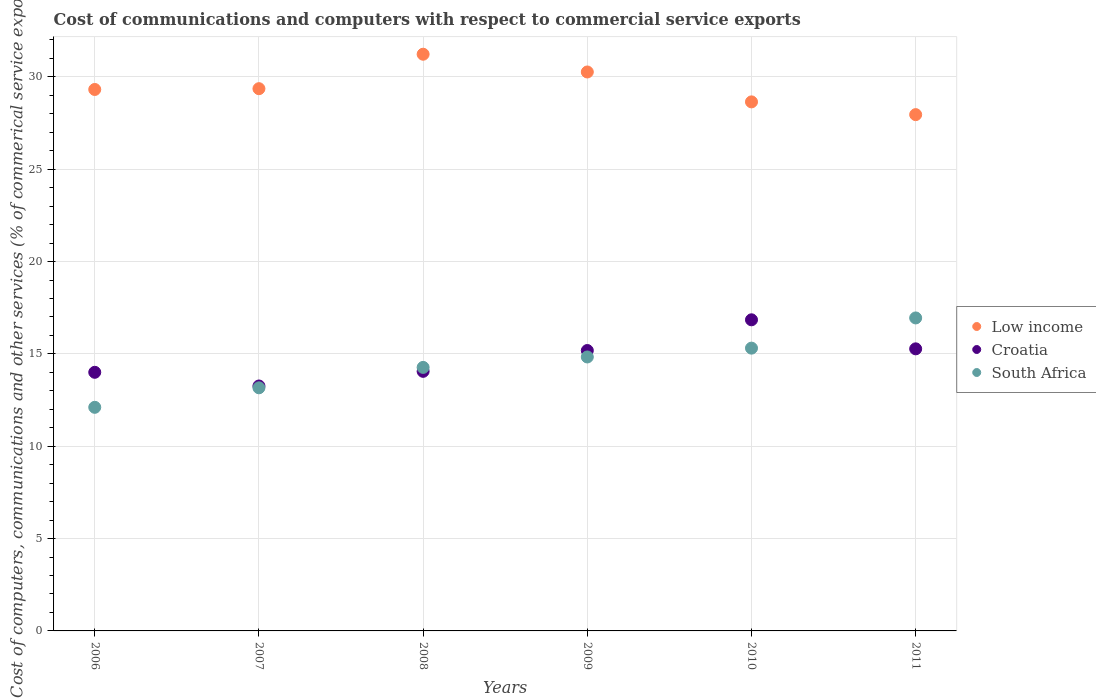Is the number of dotlines equal to the number of legend labels?
Make the answer very short. Yes. What is the cost of communications and computers in South Africa in 2009?
Provide a succinct answer. 14.84. Across all years, what is the maximum cost of communications and computers in Croatia?
Your answer should be very brief. 16.85. Across all years, what is the minimum cost of communications and computers in Low income?
Provide a succinct answer. 27.96. In which year was the cost of communications and computers in Croatia minimum?
Your answer should be compact. 2007. What is the total cost of communications and computers in Croatia in the graph?
Ensure brevity in your answer.  88.63. What is the difference between the cost of communications and computers in Low income in 2007 and that in 2009?
Offer a terse response. -0.9. What is the difference between the cost of communications and computers in Croatia in 2006 and the cost of communications and computers in South Africa in 2011?
Provide a short and direct response. -2.94. What is the average cost of communications and computers in Croatia per year?
Offer a terse response. 14.77. In the year 2010, what is the difference between the cost of communications and computers in South Africa and cost of communications and computers in Croatia?
Ensure brevity in your answer.  -1.53. In how many years, is the cost of communications and computers in Croatia greater than 2 %?
Offer a terse response. 6. What is the ratio of the cost of communications and computers in Croatia in 2009 to that in 2011?
Provide a short and direct response. 0.99. Is the cost of communications and computers in South Africa in 2007 less than that in 2010?
Offer a very short reply. Yes. Is the difference between the cost of communications and computers in South Africa in 2006 and 2008 greater than the difference between the cost of communications and computers in Croatia in 2006 and 2008?
Your answer should be very brief. No. What is the difference between the highest and the second highest cost of communications and computers in South Africa?
Give a very brief answer. 1.64. What is the difference between the highest and the lowest cost of communications and computers in Low income?
Provide a succinct answer. 3.27. In how many years, is the cost of communications and computers in South Africa greater than the average cost of communications and computers in South Africa taken over all years?
Ensure brevity in your answer.  3. Does the cost of communications and computers in South Africa monotonically increase over the years?
Ensure brevity in your answer.  Yes. Is the cost of communications and computers in Low income strictly less than the cost of communications and computers in South Africa over the years?
Give a very brief answer. No. How many dotlines are there?
Your answer should be compact. 3. Are the values on the major ticks of Y-axis written in scientific E-notation?
Provide a short and direct response. No. Does the graph contain any zero values?
Offer a terse response. No. Does the graph contain grids?
Provide a succinct answer. Yes. What is the title of the graph?
Offer a very short reply. Cost of communications and computers with respect to commercial service exports. Does "Vietnam" appear as one of the legend labels in the graph?
Provide a short and direct response. No. What is the label or title of the Y-axis?
Keep it short and to the point. Cost of computers, communications and other services (% of commerical service exports). What is the Cost of computers, communications and other services (% of commerical service exports) of Low income in 2006?
Provide a succinct answer. 29.32. What is the Cost of computers, communications and other services (% of commerical service exports) of Croatia in 2006?
Keep it short and to the point. 14. What is the Cost of computers, communications and other services (% of commerical service exports) of South Africa in 2006?
Make the answer very short. 12.11. What is the Cost of computers, communications and other services (% of commerical service exports) of Low income in 2007?
Your response must be concise. 29.36. What is the Cost of computers, communications and other services (% of commerical service exports) of Croatia in 2007?
Keep it short and to the point. 13.26. What is the Cost of computers, communications and other services (% of commerical service exports) of South Africa in 2007?
Your response must be concise. 13.17. What is the Cost of computers, communications and other services (% of commerical service exports) of Low income in 2008?
Provide a succinct answer. 31.23. What is the Cost of computers, communications and other services (% of commerical service exports) of Croatia in 2008?
Keep it short and to the point. 14.06. What is the Cost of computers, communications and other services (% of commerical service exports) of South Africa in 2008?
Give a very brief answer. 14.27. What is the Cost of computers, communications and other services (% of commerical service exports) in Low income in 2009?
Provide a short and direct response. 30.27. What is the Cost of computers, communications and other services (% of commerical service exports) of Croatia in 2009?
Provide a succinct answer. 15.18. What is the Cost of computers, communications and other services (% of commerical service exports) in South Africa in 2009?
Give a very brief answer. 14.84. What is the Cost of computers, communications and other services (% of commerical service exports) in Low income in 2010?
Make the answer very short. 28.65. What is the Cost of computers, communications and other services (% of commerical service exports) in Croatia in 2010?
Make the answer very short. 16.85. What is the Cost of computers, communications and other services (% of commerical service exports) in South Africa in 2010?
Your answer should be very brief. 15.31. What is the Cost of computers, communications and other services (% of commerical service exports) of Low income in 2011?
Keep it short and to the point. 27.96. What is the Cost of computers, communications and other services (% of commerical service exports) of Croatia in 2011?
Your answer should be very brief. 15.28. What is the Cost of computers, communications and other services (% of commerical service exports) in South Africa in 2011?
Provide a succinct answer. 16.95. Across all years, what is the maximum Cost of computers, communications and other services (% of commerical service exports) in Low income?
Provide a short and direct response. 31.23. Across all years, what is the maximum Cost of computers, communications and other services (% of commerical service exports) in Croatia?
Offer a terse response. 16.85. Across all years, what is the maximum Cost of computers, communications and other services (% of commerical service exports) in South Africa?
Provide a succinct answer. 16.95. Across all years, what is the minimum Cost of computers, communications and other services (% of commerical service exports) in Low income?
Your response must be concise. 27.96. Across all years, what is the minimum Cost of computers, communications and other services (% of commerical service exports) of Croatia?
Offer a terse response. 13.26. Across all years, what is the minimum Cost of computers, communications and other services (% of commerical service exports) of South Africa?
Offer a terse response. 12.11. What is the total Cost of computers, communications and other services (% of commerical service exports) in Low income in the graph?
Offer a very short reply. 176.79. What is the total Cost of computers, communications and other services (% of commerical service exports) in Croatia in the graph?
Offer a very short reply. 88.63. What is the total Cost of computers, communications and other services (% of commerical service exports) in South Africa in the graph?
Your answer should be compact. 86.64. What is the difference between the Cost of computers, communications and other services (% of commerical service exports) in Low income in 2006 and that in 2007?
Your response must be concise. -0.04. What is the difference between the Cost of computers, communications and other services (% of commerical service exports) of Croatia in 2006 and that in 2007?
Provide a succinct answer. 0.74. What is the difference between the Cost of computers, communications and other services (% of commerical service exports) of South Africa in 2006 and that in 2007?
Ensure brevity in your answer.  -1.06. What is the difference between the Cost of computers, communications and other services (% of commerical service exports) of Low income in 2006 and that in 2008?
Your answer should be very brief. -1.91. What is the difference between the Cost of computers, communications and other services (% of commerical service exports) of Croatia in 2006 and that in 2008?
Your answer should be very brief. -0.05. What is the difference between the Cost of computers, communications and other services (% of commerical service exports) in South Africa in 2006 and that in 2008?
Your answer should be very brief. -2.16. What is the difference between the Cost of computers, communications and other services (% of commerical service exports) of Low income in 2006 and that in 2009?
Your response must be concise. -0.95. What is the difference between the Cost of computers, communications and other services (% of commerical service exports) of Croatia in 2006 and that in 2009?
Provide a succinct answer. -1.18. What is the difference between the Cost of computers, communications and other services (% of commerical service exports) in South Africa in 2006 and that in 2009?
Make the answer very short. -2.73. What is the difference between the Cost of computers, communications and other services (% of commerical service exports) of Low income in 2006 and that in 2010?
Ensure brevity in your answer.  0.67. What is the difference between the Cost of computers, communications and other services (% of commerical service exports) of Croatia in 2006 and that in 2010?
Ensure brevity in your answer.  -2.84. What is the difference between the Cost of computers, communications and other services (% of commerical service exports) of South Africa in 2006 and that in 2010?
Offer a very short reply. -3.21. What is the difference between the Cost of computers, communications and other services (% of commerical service exports) of Low income in 2006 and that in 2011?
Offer a very short reply. 1.36. What is the difference between the Cost of computers, communications and other services (% of commerical service exports) of Croatia in 2006 and that in 2011?
Your response must be concise. -1.27. What is the difference between the Cost of computers, communications and other services (% of commerical service exports) of South Africa in 2006 and that in 2011?
Ensure brevity in your answer.  -4.84. What is the difference between the Cost of computers, communications and other services (% of commerical service exports) of Low income in 2007 and that in 2008?
Your answer should be compact. -1.87. What is the difference between the Cost of computers, communications and other services (% of commerical service exports) in Croatia in 2007 and that in 2008?
Provide a succinct answer. -0.79. What is the difference between the Cost of computers, communications and other services (% of commerical service exports) in South Africa in 2007 and that in 2008?
Your answer should be compact. -1.11. What is the difference between the Cost of computers, communications and other services (% of commerical service exports) of Low income in 2007 and that in 2009?
Make the answer very short. -0.9. What is the difference between the Cost of computers, communications and other services (% of commerical service exports) in Croatia in 2007 and that in 2009?
Offer a very short reply. -1.92. What is the difference between the Cost of computers, communications and other services (% of commerical service exports) in South Africa in 2007 and that in 2009?
Ensure brevity in your answer.  -1.67. What is the difference between the Cost of computers, communications and other services (% of commerical service exports) in Low income in 2007 and that in 2010?
Offer a terse response. 0.71. What is the difference between the Cost of computers, communications and other services (% of commerical service exports) of Croatia in 2007 and that in 2010?
Your response must be concise. -3.58. What is the difference between the Cost of computers, communications and other services (% of commerical service exports) of South Africa in 2007 and that in 2010?
Your answer should be compact. -2.15. What is the difference between the Cost of computers, communications and other services (% of commerical service exports) of Low income in 2007 and that in 2011?
Provide a succinct answer. 1.41. What is the difference between the Cost of computers, communications and other services (% of commerical service exports) of Croatia in 2007 and that in 2011?
Provide a succinct answer. -2.01. What is the difference between the Cost of computers, communications and other services (% of commerical service exports) of South Africa in 2007 and that in 2011?
Offer a very short reply. -3.78. What is the difference between the Cost of computers, communications and other services (% of commerical service exports) in Low income in 2008 and that in 2009?
Make the answer very short. 0.96. What is the difference between the Cost of computers, communications and other services (% of commerical service exports) in Croatia in 2008 and that in 2009?
Your answer should be compact. -1.13. What is the difference between the Cost of computers, communications and other services (% of commerical service exports) in South Africa in 2008 and that in 2009?
Ensure brevity in your answer.  -0.56. What is the difference between the Cost of computers, communications and other services (% of commerical service exports) of Low income in 2008 and that in 2010?
Your answer should be very brief. 2.58. What is the difference between the Cost of computers, communications and other services (% of commerical service exports) in Croatia in 2008 and that in 2010?
Offer a very short reply. -2.79. What is the difference between the Cost of computers, communications and other services (% of commerical service exports) in South Africa in 2008 and that in 2010?
Your answer should be compact. -1.04. What is the difference between the Cost of computers, communications and other services (% of commerical service exports) of Low income in 2008 and that in 2011?
Your answer should be compact. 3.27. What is the difference between the Cost of computers, communications and other services (% of commerical service exports) in Croatia in 2008 and that in 2011?
Your answer should be compact. -1.22. What is the difference between the Cost of computers, communications and other services (% of commerical service exports) in South Africa in 2008 and that in 2011?
Provide a succinct answer. -2.68. What is the difference between the Cost of computers, communications and other services (% of commerical service exports) of Low income in 2009 and that in 2010?
Offer a terse response. 1.62. What is the difference between the Cost of computers, communications and other services (% of commerical service exports) in Croatia in 2009 and that in 2010?
Offer a terse response. -1.66. What is the difference between the Cost of computers, communications and other services (% of commerical service exports) of South Africa in 2009 and that in 2010?
Give a very brief answer. -0.48. What is the difference between the Cost of computers, communications and other services (% of commerical service exports) of Low income in 2009 and that in 2011?
Make the answer very short. 2.31. What is the difference between the Cost of computers, communications and other services (% of commerical service exports) in Croatia in 2009 and that in 2011?
Provide a succinct answer. -0.09. What is the difference between the Cost of computers, communications and other services (% of commerical service exports) of South Africa in 2009 and that in 2011?
Provide a short and direct response. -2.11. What is the difference between the Cost of computers, communications and other services (% of commerical service exports) in Low income in 2010 and that in 2011?
Offer a very short reply. 0.69. What is the difference between the Cost of computers, communications and other services (% of commerical service exports) in Croatia in 2010 and that in 2011?
Give a very brief answer. 1.57. What is the difference between the Cost of computers, communications and other services (% of commerical service exports) in South Africa in 2010 and that in 2011?
Offer a very short reply. -1.64. What is the difference between the Cost of computers, communications and other services (% of commerical service exports) of Low income in 2006 and the Cost of computers, communications and other services (% of commerical service exports) of Croatia in 2007?
Offer a very short reply. 16.06. What is the difference between the Cost of computers, communications and other services (% of commerical service exports) in Low income in 2006 and the Cost of computers, communications and other services (% of commerical service exports) in South Africa in 2007?
Offer a very short reply. 16.16. What is the difference between the Cost of computers, communications and other services (% of commerical service exports) of Croatia in 2006 and the Cost of computers, communications and other services (% of commerical service exports) of South Africa in 2007?
Provide a short and direct response. 0.84. What is the difference between the Cost of computers, communications and other services (% of commerical service exports) in Low income in 2006 and the Cost of computers, communications and other services (% of commerical service exports) in Croatia in 2008?
Offer a very short reply. 15.26. What is the difference between the Cost of computers, communications and other services (% of commerical service exports) of Low income in 2006 and the Cost of computers, communications and other services (% of commerical service exports) of South Africa in 2008?
Make the answer very short. 15.05. What is the difference between the Cost of computers, communications and other services (% of commerical service exports) in Croatia in 2006 and the Cost of computers, communications and other services (% of commerical service exports) in South Africa in 2008?
Keep it short and to the point. -0.27. What is the difference between the Cost of computers, communications and other services (% of commerical service exports) in Low income in 2006 and the Cost of computers, communications and other services (% of commerical service exports) in Croatia in 2009?
Your answer should be compact. 14.14. What is the difference between the Cost of computers, communications and other services (% of commerical service exports) of Low income in 2006 and the Cost of computers, communications and other services (% of commerical service exports) of South Africa in 2009?
Make the answer very short. 14.49. What is the difference between the Cost of computers, communications and other services (% of commerical service exports) in Croatia in 2006 and the Cost of computers, communications and other services (% of commerical service exports) in South Africa in 2009?
Your response must be concise. -0.83. What is the difference between the Cost of computers, communications and other services (% of commerical service exports) in Low income in 2006 and the Cost of computers, communications and other services (% of commerical service exports) in Croatia in 2010?
Keep it short and to the point. 12.47. What is the difference between the Cost of computers, communications and other services (% of commerical service exports) in Low income in 2006 and the Cost of computers, communications and other services (% of commerical service exports) in South Africa in 2010?
Offer a terse response. 14.01. What is the difference between the Cost of computers, communications and other services (% of commerical service exports) in Croatia in 2006 and the Cost of computers, communications and other services (% of commerical service exports) in South Africa in 2010?
Your answer should be compact. -1.31. What is the difference between the Cost of computers, communications and other services (% of commerical service exports) of Low income in 2006 and the Cost of computers, communications and other services (% of commerical service exports) of Croatia in 2011?
Make the answer very short. 14.05. What is the difference between the Cost of computers, communications and other services (% of commerical service exports) of Low income in 2006 and the Cost of computers, communications and other services (% of commerical service exports) of South Africa in 2011?
Offer a very short reply. 12.37. What is the difference between the Cost of computers, communications and other services (% of commerical service exports) in Croatia in 2006 and the Cost of computers, communications and other services (% of commerical service exports) in South Africa in 2011?
Offer a very short reply. -2.94. What is the difference between the Cost of computers, communications and other services (% of commerical service exports) of Low income in 2007 and the Cost of computers, communications and other services (% of commerical service exports) of Croatia in 2008?
Give a very brief answer. 15.31. What is the difference between the Cost of computers, communications and other services (% of commerical service exports) in Low income in 2007 and the Cost of computers, communications and other services (% of commerical service exports) in South Africa in 2008?
Make the answer very short. 15.09. What is the difference between the Cost of computers, communications and other services (% of commerical service exports) of Croatia in 2007 and the Cost of computers, communications and other services (% of commerical service exports) of South Africa in 2008?
Your answer should be compact. -1.01. What is the difference between the Cost of computers, communications and other services (% of commerical service exports) in Low income in 2007 and the Cost of computers, communications and other services (% of commerical service exports) in Croatia in 2009?
Give a very brief answer. 14.18. What is the difference between the Cost of computers, communications and other services (% of commerical service exports) in Low income in 2007 and the Cost of computers, communications and other services (% of commerical service exports) in South Africa in 2009?
Offer a very short reply. 14.53. What is the difference between the Cost of computers, communications and other services (% of commerical service exports) in Croatia in 2007 and the Cost of computers, communications and other services (% of commerical service exports) in South Africa in 2009?
Offer a very short reply. -1.57. What is the difference between the Cost of computers, communications and other services (% of commerical service exports) in Low income in 2007 and the Cost of computers, communications and other services (% of commerical service exports) in Croatia in 2010?
Your response must be concise. 12.52. What is the difference between the Cost of computers, communications and other services (% of commerical service exports) in Low income in 2007 and the Cost of computers, communications and other services (% of commerical service exports) in South Africa in 2010?
Ensure brevity in your answer.  14.05. What is the difference between the Cost of computers, communications and other services (% of commerical service exports) of Croatia in 2007 and the Cost of computers, communications and other services (% of commerical service exports) of South Africa in 2010?
Your answer should be very brief. -2.05. What is the difference between the Cost of computers, communications and other services (% of commerical service exports) of Low income in 2007 and the Cost of computers, communications and other services (% of commerical service exports) of Croatia in 2011?
Ensure brevity in your answer.  14.09. What is the difference between the Cost of computers, communications and other services (% of commerical service exports) of Low income in 2007 and the Cost of computers, communications and other services (% of commerical service exports) of South Africa in 2011?
Your answer should be very brief. 12.41. What is the difference between the Cost of computers, communications and other services (% of commerical service exports) of Croatia in 2007 and the Cost of computers, communications and other services (% of commerical service exports) of South Africa in 2011?
Keep it short and to the point. -3.69. What is the difference between the Cost of computers, communications and other services (% of commerical service exports) in Low income in 2008 and the Cost of computers, communications and other services (% of commerical service exports) in Croatia in 2009?
Keep it short and to the point. 16.05. What is the difference between the Cost of computers, communications and other services (% of commerical service exports) in Low income in 2008 and the Cost of computers, communications and other services (% of commerical service exports) in South Africa in 2009?
Offer a very short reply. 16.39. What is the difference between the Cost of computers, communications and other services (% of commerical service exports) of Croatia in 2008 and the Cost of computers, communications and other services (% of commerical service exports) of South Africa in 2009?
Offer a terse response. -0.78. What is the difference between the Cost of computers, communications and other services (% of commerical service exports) of Low income in 2008 and the Cost of computers, communications and other services (% of commerical service exports) of Croatia in 2010?
Give a very brief answer. 14.38. What is the difference between the Cost of computers, communications and other services (% of commerical service exports) in Low income in 2008 and the Cost of computers, communications and other services (% of commerical service exports) in South Africa in 2010?
Provide a short and direct response. 15.92. What is the difference between the Cost of computers, communications and other services (% of commerical service exports) of Croatia in 2008 and the Cost of computers, communications and other services (% of commerical service exports) of South Africa in 2010?
Provide a succinct answer. -1.26. What is the difference between the Cost of computers, communications and other services (% of commerical service exports) of Low income in 2008 and the Cost of computers, communications and other services (% of commerical service exports) of Croatia in 2011?
Provide a succinct answer. 15.95. What is the difference between the Cost of computers, communications and other services (% of commerical service exports) of Low income in 2008 and the Cost of computers, communications and other services (% of commerical service exports) of South Africa in 2011?
Make the answer very short. 14.28. What is the difference between the Cost of computers, communications and other services (% of commerical service exports) of Croatia in 2008 and the Cost of computers, communications and other services (% of commerical service exports) of South Africa in 2011?
Your answer should be compact. -2.89. What is the difference between the Cost of computers, communications and other services (% of commerical service exports) in Low income in 2009 and the Cost of computers, communications and other services (% of commerical service exports) in Croatia in 2010?
Provide a short and direct response. 13.42. What is the difference between the Cost of computers, communications and other services (% of commerical service exports) of Low income in 2009 and the Cost of computers, communications and other services (% of commerical service exports) of South Africa in 2010?
Provide a succinct answer. 14.95. What is the difference between the Cost of computers, communications and other services (% of commerical service exports) in Croatia in 2009 and the Cost of computers, communications and other services (% of commerical service exports) in South Africa in 2010?
Your response must be concise. -0.13. What is the difference between the Cost of computers, communications and other services (% of commerical service exports) of Low income in 2009 and the Cost of computers, communications and other services (% of commerical service exports) of Croatia in 2011?
Keep it short and to the point. 14.99. What is the difference between the Cost of computers, communications and other services (% of commerical service exports) in Low income in 2009 and the Cost of computers, communications and other services (% of commerical service exports) in South Africa in 2011?
Offer a terse response. 13.32. What is the difference between the Cost of computers, communications and other services (% of commerical service exports) of Croatia in 2009 and the Cost of computers, communications and other services (% of commerical service exports) of South Africa in 2011?
Provide a short and direct response. -1.76. What is the difference between the Cost of computers, communications and other services (% of commerical service exports) of Low income in 2010 and the Cost of computers, communications and other services (% of commerical service exports) of Croatia in 2011?
Make the answer very short. 13.37. What is the difference between the Cost of computers, communications and other services (% of commerical service exports) in Croatia in 2010 and the Cost of computers, communications and other services (% of commerical service exports) in South Africa in 2011?
Provide a succinct answer. -0.1. What is the average Cost of computers, communications and other services (% of commerical service exports) in Low income per year?
Provide a short and direct response. 29.46. What is the average Cost of computers, communications and other services (% of commerical service exports) of Croatia per year?
Ensure brevity in your answer.  14.77. What is the average Cost of computers, communications and other services (% of commerical service exports) in South Africa per year?
Your response must be concise. 14.44. In the year 2006, what is the difference between the Cost of computers, communications and other services (% of commerical service exports) in Low income and Cost of computers, communications and other services (% of commerical service exports) in Croatia?
Ensure brevity in your answer.  15.32. In the year 2006, what is the difference between the Cost of computers, communications and other services (% of commerical service exports) of Low income and Cost of computers, communications and other services (% of commerical service exports) of South Africa?
Ensure brevity in your answer.  17.21. In the year 2006, what is the difference between the Cost of computers, communications and other services (% of commerical service exports) of Croatia and Cost of computers, communications and other services (% of commerical service exports) of South Africa?
Give a very brief answer. 1.9. In the year 2007, what is the difference between the Cost of computers, communications and other services (% of commerical service exports) in Low income and Cost of computers, communications and other services (% of commerical service exports) in Croatia?
Ensure brevity in your answer.  16.1. In the year 2007, what is the difference between the Cost of computers, communications and other services (% of commerical service exports) in Low income and Cost of computers, communications and other services (% of commerical service exports) in South Africa?
Your answer should be compact. 16.2. In the year 2007, what is the difference between the Cost of computers, communications and other services (% of commerical service exports) in Croatia and Cost of computers, communications and other services (% of commerical service exports) in South Africa?
Ensure brevity in your answer.  0.1. In the year 2008, what is the difference between the Cost of computers, communications and other services (% of commerical service exports) of Low income and Cost of computers, communications and other services (% of commerical service exports) of Croatia?
Offer a terse response. 17.17. In the year 2008, what is the difference between the Cost of computers, communications and other services (% of commerical service exports) in Low income and Cost of computers, communications and other services (% of commerical service exports) in South Africa?
Offer a terse response. 16.96. In the year 2008, what is the difference between the Cost of computers, communications and other services (% of commerical service exports) in Croatia and Cost of computers, communications and other services (% of commerical service exports) in South Africa?
Your answer should be compact. -0.21. In the year 2009, what is the difference between the Cost of computers, communications and other services (% of commerical service exports) in Low income and Cost of computers, communications and other services (% of commerical service exports) in Croatia?
Offer a very short reply. 15.08. In the year 2009, what is the difference between the Cost of computers, communications and other services (% of commerical service exports) of Low income and Cost of computers, communications and other services (% of commerical service exports) of South Africa?
Your answer should be compact. 15.43. In the year 2009, what is the difference between the Cost of computers, communications and other services (% of commerical service exports) of Croatia and Cost of computers, communications and other services (% of commerical service exports) of South Africa?
Provide a short and direct response. 0.35. In the year 2010, what is the difference between the Cost of computers, communications and other services (% of commerical service exports) in Low income and Cost of computers, communications and other services (% of commerical service exports) in Croatia?
Keep it short and to the point. 11.8. In the year 2010, what is the difference between the Cost of computers, communications and other services (% of commerical service exports) of Low income and Cost of computers, communications and other services (% of commerical service exports) of South Africa?
Keep it short and to the point. 13.34. In the year 2010, what is the difference between the Cost of computers, communications and other services (% of commerical service exports) of Croatia and Cost of computers, communications and other services (% of commerical service exports) of South Africa?
Give a very brief answer. 1.53. In the year 2011, what is the difference between the Cost of computers, communications and other services (% of commerical service exports) of Low income and Cost of computers, communications and other services (% of commerical service exports) of Croatia?
Provide a short and direct response. 12.68. In the year 2011, what is the difference between the Cost of computers, communications and other services (% of commerical service exports) of Low income and Cost of computers, communications and other services (% of commerical service exports) of South Africa?
Your response must be concise. 11.01. In the year 2011, what is the difference between the Cost of computers, communications and other services (% of commerical service exports) in Croatia and Cost of computers, communications and other services (% of commerical service exports) in South Africa?
Offer a terse response. -1.67. What is the ratio of the Cost of computers, communications and other services (% of commerical service exports) in Low income in 2006 to that in 2007?
Provide a short and direct response. 1. What is the ratio of the Cost of computers, communications and other services (% of commerical service exports) in Croatia in 2006 to that in 2007?
Ensure brevity in your answer.  1.06. What is the ratio of the Cost of computers, communications and other services (% of commerical service exports) in South Africa in 2006 to that in 2007?
Offer a terse response. 0.92. What is the ratio of the Cost of computers, communications and other services (% of commerical service exports) in Low income in 2006 to that in 2008?
Offer a terse response. 0.94. What is the ratio of the Cost of computers, communications and other services (% of commerical service exports) of South Africa in 2006 to that in 2008?
Provide a succinct answer. 0.85. What is the ratio of the Cost of computers, communications and other services (% of commerical service exports) in Low income in 2006 to that in 2009?
Your answer should be compact. 0.97. What is the ratio of the Cost of computers, communications and other services (% of commerical service exports) of Croatia in 2006 to that in 2009?
Your answer should be compact. 0.92. What is the ratio of the Cost of computers, communications and other services (% of commerical service exports) in South Africa in 2006 to that in 2009?
Your answer should be very brief. 0.82. What is the ratio of the Cost of computers, communications and other services (% of commerical service exports) in Low income in 2006 to that in 2010?
Give a very brief answer. 1.02. What is the ratio of the Cost of computers, communications and other services (% of commerical service exports) in Croatia in 2006 to that in 2010?
Provide a succinct answer. 0.83. What is the ratio of the Cost of computers, communications and other services (% of commerical service exports) in South Africa in 2006 to that in 2010?
Keep it short and to the point. 0.79. What is the ratio of the Cost of computers, communications and other services (% of commerical service exports) of Low income in 2006 to that in 2011?
Ensure brevity in your answer.  1.05. What is the ratio of the Cost of computers, communications and other services (% of commerical service exports) of Croatia in 2006 to that in 2011?
Provide a short and direct response. 0.92. What is the ratio of the Cost of computers, communications and other services (% of commerical service exports) of South Africa in 2006 to that in 2011?
Your response must be concise. 0.71. What is the ratio of the Cost of computers, communications and other services (% of commerical service exports) of Low income in 2007 to that in 2008?
Keep it short and to the point. 0.94. What is the ratio of the Cost of computers, communications and other services (% of commerical service exports) of Croatia in 2007 to that in 2008?
Your response must be concise. 0.94. What is the ratio of the Cost of computers, communications and other services (% of commerical service exports) in South Africa in 2007 to that in 2008?
Provide a short and direct response. 0.92. What is the ratio of the Cost of computers, communications and other services (% of commerical service exports) of Low income in 2007 to that in 2009?
Offer a terse response. 0.97. What is the ratio of the Cost of computers, communications and other services (% of commerical service exports) in Croatia in 2007 to that in 2009?
Give a very brief answer. 0.87. What is the ratio of the Cost of computers, communications and other services (% of commerical service exports) in South Africa in 2007 to that in 2009?
Your response must be concise. 0.89. What is the ratio of the Cost of computers, communications and other services (% of commerical service exports) of Croatia in 2007 to that in 2010?
Keep it short and to the point. 0.79. What is the ratio of the Cost of computers, communications and other services (% of commerical service exports) in South Africa in 2007 to that in 2010?
Give a very brief answer. 0.86. What is the ratio of the Cost of computers, communications and other services (% of commerical service exports) of Low income in 2007 to that in 2011?
Your answer should be very brief. 1.05. What is the ratio of the Cost of computers, communications and other services (% of commerical service exports) of Croatia in 2007 to that in 2011?
Your answer should be compact. 0.87. What is the ratio of the Cost of computers, communications and other services (% of commerical service exports) of South Africa in 2007 to that in 2011?
Your answer should be very brief. 0.78. What is the ratio of the Cost of computers, communications and other services (% of commerical service exports) of Low income in 2008 to that in 2009?
Provide a succinct answer. 1.03. What is the ratio of the Cost of computers, communications and other services (% of commerical service exports) of Croatia in 2008 to that in 2009?
Your response must be concise. 0.93. What is the ratio of the Cost of computers, communications and other services (% of commerical service exports) of South Africa in 2008 to that in 2009?
Your answer should be very brief. 0.96. What is the ratio of the Cost of computers, communications and other services (% of commerical service exports) of Low income in 2008 to that in 2010?
Ensure brevity in your answer.  1.09. What is the ratio of the Cost of computers, communications and other services (% of commerical service exports) in Croatia in 2008 to that in 2010?
Keep it short and to the point. 0.83. What is the ratio of the Cost of computers, communications and other services (% of commerical service exports) in South Africa in 2008 to that in 2010?
Make the answer very short. 0.93. What is the ratio of the Cost of computers, communications and other services (% of commerical service exports) of Low income in 2008 to that in 2011?
Ensure brevity in your answer.  1.12. What is the ratio of the Cost of computers, communications and other services (% of commerical service exports) of Croatia in 2008 to that in 2011?
Ensure brevity in your answer.  0.92. What is the ratio of the Cost of computers, communications and other services (% of commerical service exports) of South Africa in 2008 to that in 2011?
Your response must be concise. 0.84. What is the ratio of the Cost of computers, communications and other services (% of commerical service exports) in Low income in 2009 to that in 2010?
Provide a short and direct response. 1.06. What is the ratio of the Cost of computers, communications and other services (% of commerical service exports) of Croatia in 2009 to that in 2010?
Your answer should be compact. 0.9. What is the ratio of the Cost of computers, communications and other services (% of commerical service exports) of South Africa in 2009 to that in 2010?
Make the answer very short. 0.97. What is the ratio of the Cost of computers, communications and other services (% of commerical service exports) of Low income in 2009 to that in 2011?
Your response must be concise. 1.08. What is the ratio of the Cost of computers, communications and other services (% of commerical service exports) of Croatia in 2009 to that in 2011?
Your answer should be compact. 0.99. What is the ratio of the Cost of computers, communications and other services (% of commerical service exports) of South Africa in 2009 to that in 2011?
Offer a terse response. 0.88. What is the ratio of the Cost of computers, communications and other services (% of commerical service exports) in Low income in 2010 to that in 2011?
Ensure brevity in your answer.  1.02. What is the ratio of the Cost of computers, communications and other services (% of commerical service exports) in Croatia in 2010 to that in 2011?
Your answer should be very brief. 1.1. What is the ratio of the Cost of computers, communications and other services (% of commerical service exports) of South Africa in 2010 to that in 2011?
Provide a succinct answer. 0.9. What is the difference between the highest and the second highest Cost of computers, communications and other services (% of commerical service exports) in Low income?
Offer a terse response. 0.96. What is the difference between the highest and the second highest Cost of computers, communications and other services (% of commerical service exports) in Croatia?
Make the answer very short. 1.57. What is the difference between the highest and the second highest Cost of computers, communications and other services (% of commerical service exports) of South Africa?
Make the answer very short. 1.64. What is the difference between the highest and the lowest Cost of computers, communications and other services (% of commerical service exports) of Low income?
Offer a terse response. 3.27. What is the difference between the highest and the lowest Cost of computers, communications and other services (% of commerical service exports) of Croatia?
Provide a succinct answer. 3.58. What is the difference between the highest and the lowest Cost of computers, communications and other services (% of commerical service exports) of South Africa?
Provide a short and direct response. 4.84. 